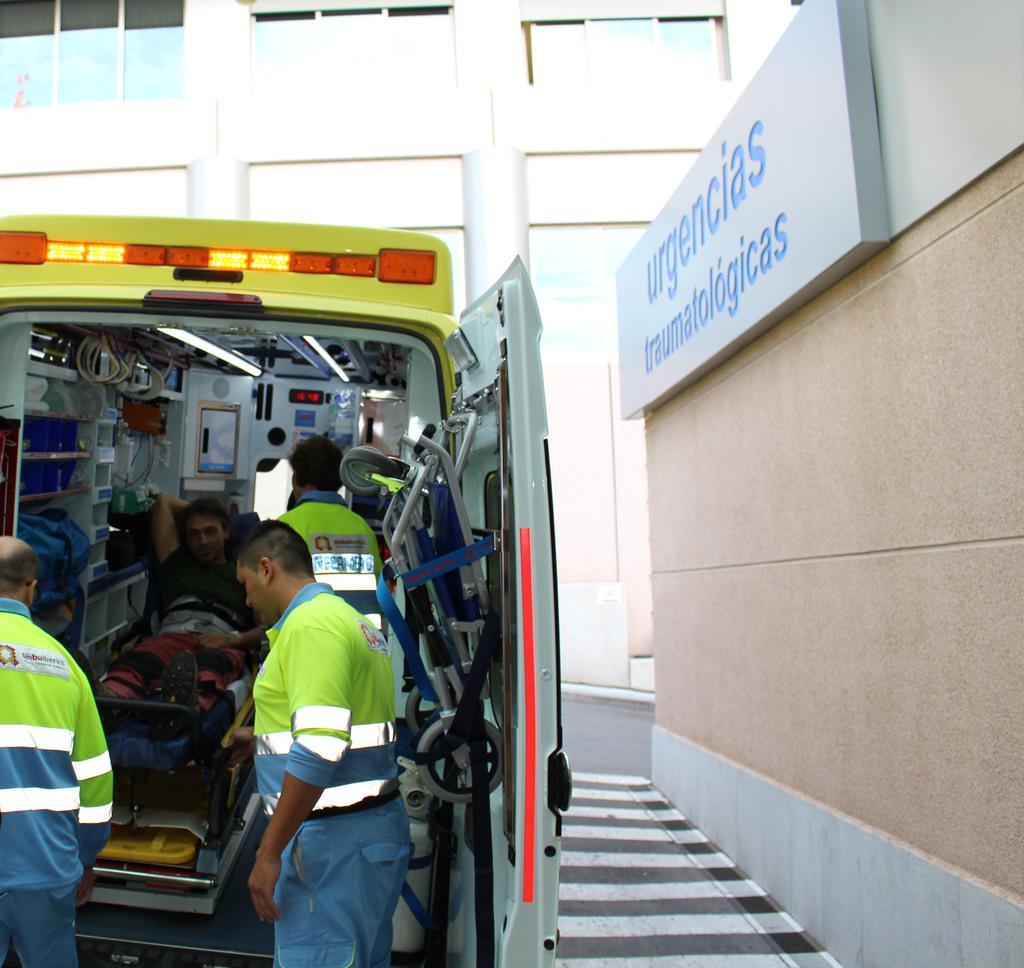Describe this image in one or two sentences. This picture is clicked outside. On the right we can see the text on the board which seems to be attached to the wall of the building and we can see the zebra crossing like thing. On the left we can see the two people standing on the ground and we can see the two people seems to be sitting in the vehicle and we can see the lights and many other objects in the vehicle. In the background we can see the building and the ground. 